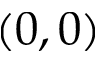<formula> <loc_0><loc_0><loc_500><loc_500>( 0 , 0 )</formula> 